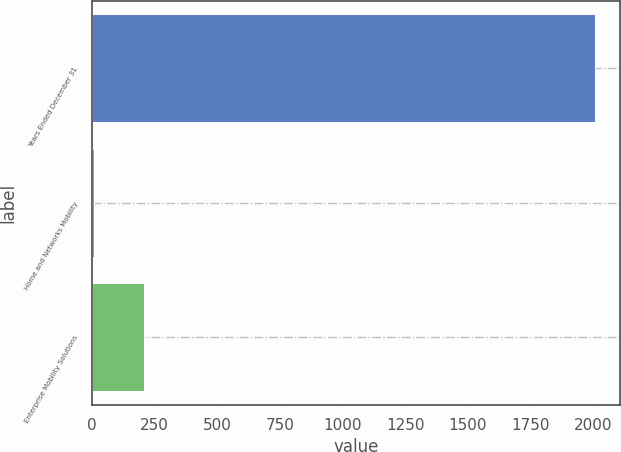<chart> <loc_0><loc_0><loc_500><loc_500><bar_chart><fcel>Years Ended December 31<fcel>Home and Networks Mobility<fcel>Enterprise Mobility Solutions<nl><fcel>2005<fcel>7<fcel>206.8<nl></chart> 